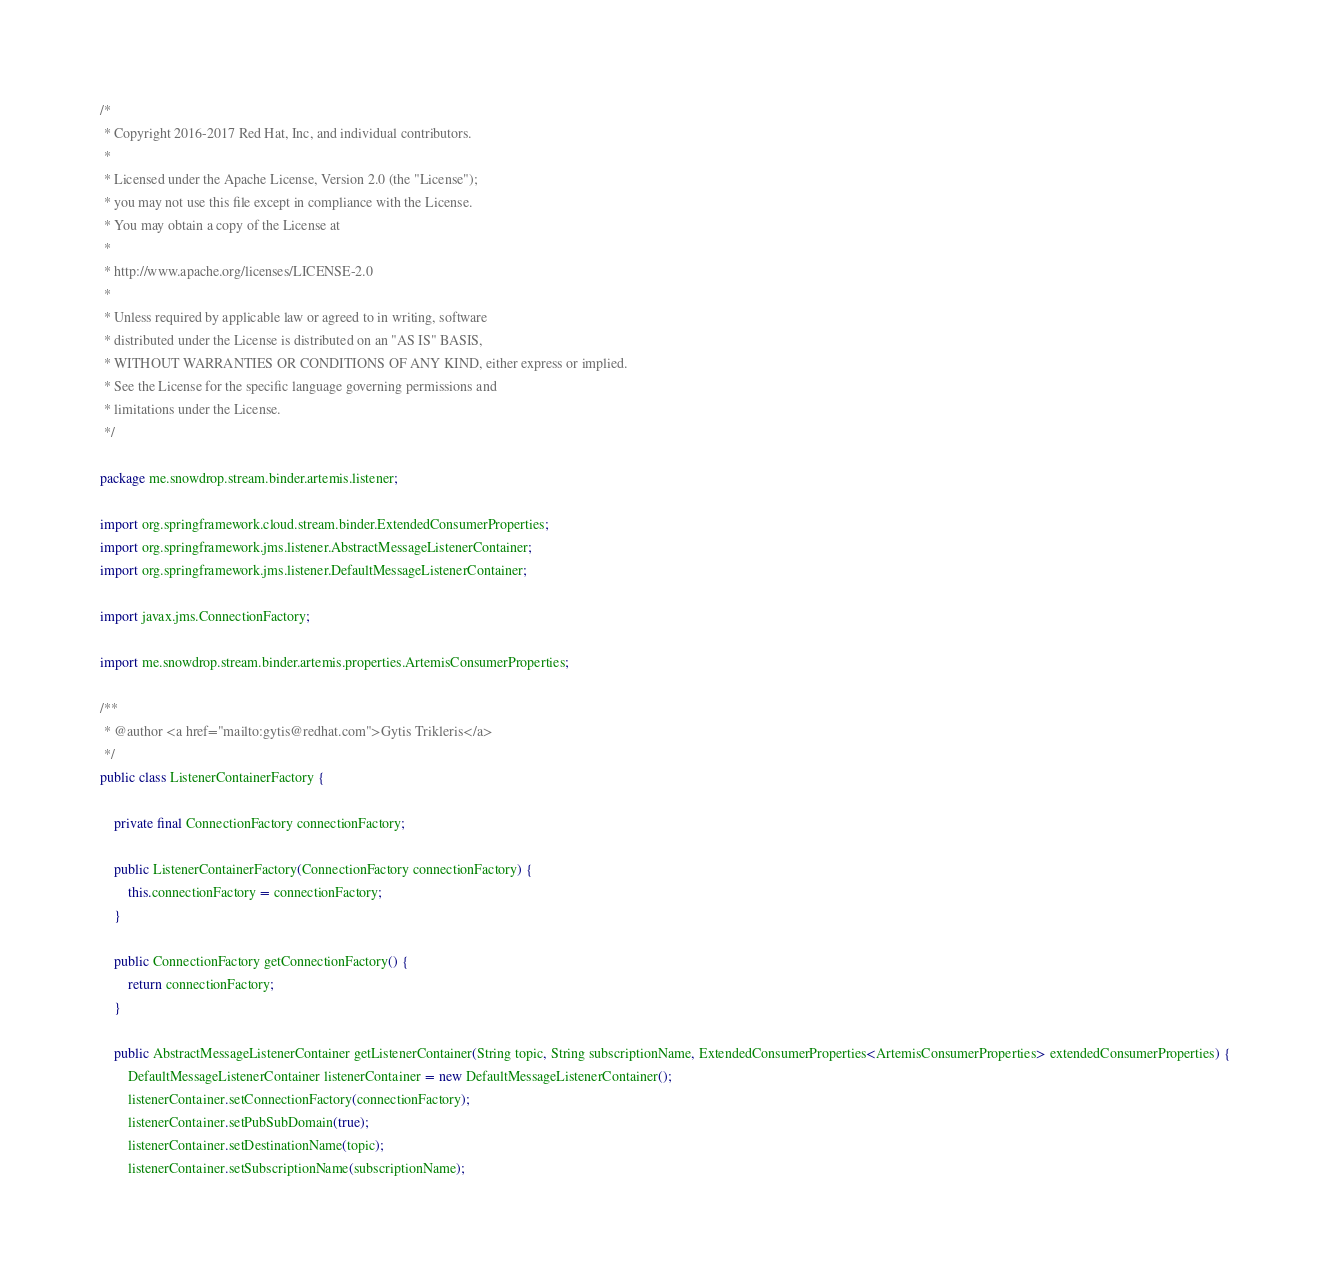<code> <loc_0><loc_0><loc_500><loc_500><_Java_>/*
 * Copyright 2016-2017 Red Hat, Inc, and individual contributors.
 *
 * Licensed under the Apache License, Version 2.0 (the "License");
 * you may not use this file except in compliance with the License.
 * You may obtain a copy of the License at
 *
 * http://www.apache.org/licenses/LICENSE-2.0
 *
 * Unless required by applicable law or agreed to in writing, software
 * distributed under the License is distributed on an "AS IS" BASIS,
 * WITHOUT WARRANTIES OR CONDITIONS OF ANY KIND, either express or implied.
 * See the License for the specific language governing permissions and
 * limitations under the License.
 */

package me.snowdrop.stream.binder.artemis.listener;

import org.springframework.cloud.stream.binder.ExtendedConsumerProperties;
import org.springframework.jms.listener.AbstractMessageListenerContainer;
import org.springframework.jms.listener.DefaultMessageListenerContainer;

import javax.jms.ConnectionFactory;

import me.snowdrop.stream.binder.artemis.properties.ArtemisConsumerProperties;

/**
 * @author <a href="mailto:gytis@redhat.com">Gytis Trikleris</a>
 */
public class ListenerContainerFactory {

    private final ConnectionFactory connectionFactory;

    public ListenerContainerFactory(ConnectionFactory connectionFactory) {
        this.connectionFactory = connectionFactory;
    }

    public ConnectionFactory getConnectionFactory() {
        return connectionFactory;
    }

    public AbstractMessageListenerContainer getListenerContainer(String topic, String subscriptionName, ExtendedConsumerProperties<ArtemisConsumerProperties> extendedConsumerProperties) {
        DefaultMessageListenerContainer listenerContainer = new DefaultMessageListenerContainer();
        listenerContainer.setConnectionFactory(connectionFactory);
        listenerContainer.setPubSubDomain(true);
        listenerContainer.setDestinationName(topic);
        listenerContainer.setSubscriptionName(subscriptionName);</code> 